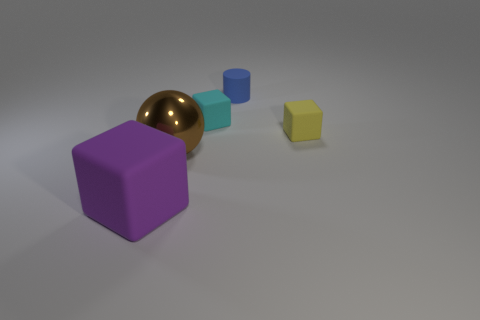There is a rubber thing that is to the left of the big brown shiny thing; what is its color?
Make the answer very short. Purple. Are there the same number of objects that are behind the blue cylinder and tiny rubber cylinders?
Offer a terse response. No. What number of other objects are the same shape as the big rubber thing?
Your answer should be compact. 2. There is a ball; how many large metallic objects are in front of it?
Your answer should be very brief. 0. What is the size of the cube that is behind the purple matte object and left of the blue matte cylinder?
Your answer should be compact. Small. Are any purple things visible?
Provide a short and direct response. Yes. What number of other things are there of the same size as the blue cylinder?
Provide a succinct answer. 2. There is a tiny matte block in front of the tiny cyan rubber object; is it the same color as the large thing right of the purple rubber cube?
Your response must be concise. No. There is a yellow thing that is the same shape as the small cyan object; what size is it?
Your response must be concise. Small. Does the large object that is right of the purple object have the same material as the tiny block right of the small cyan thing?
Offer a very short reply. No. 